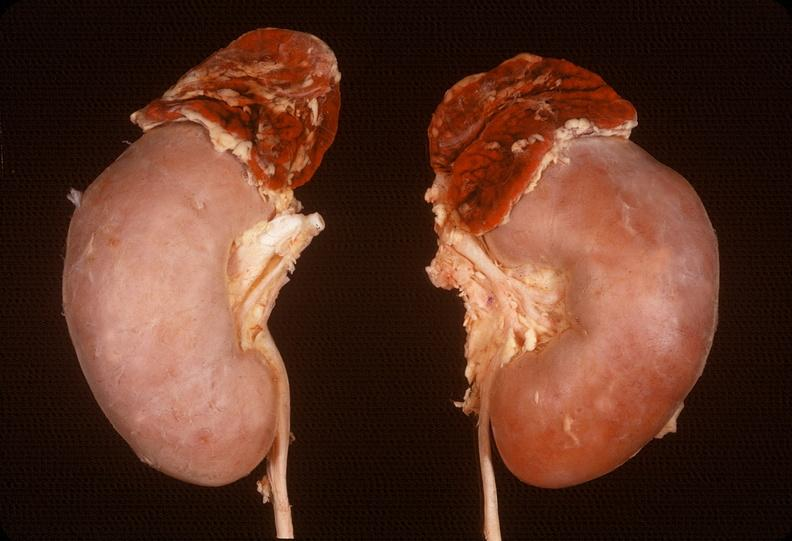s endocrine present?
Answer the question using a single word or phrase. Yes 